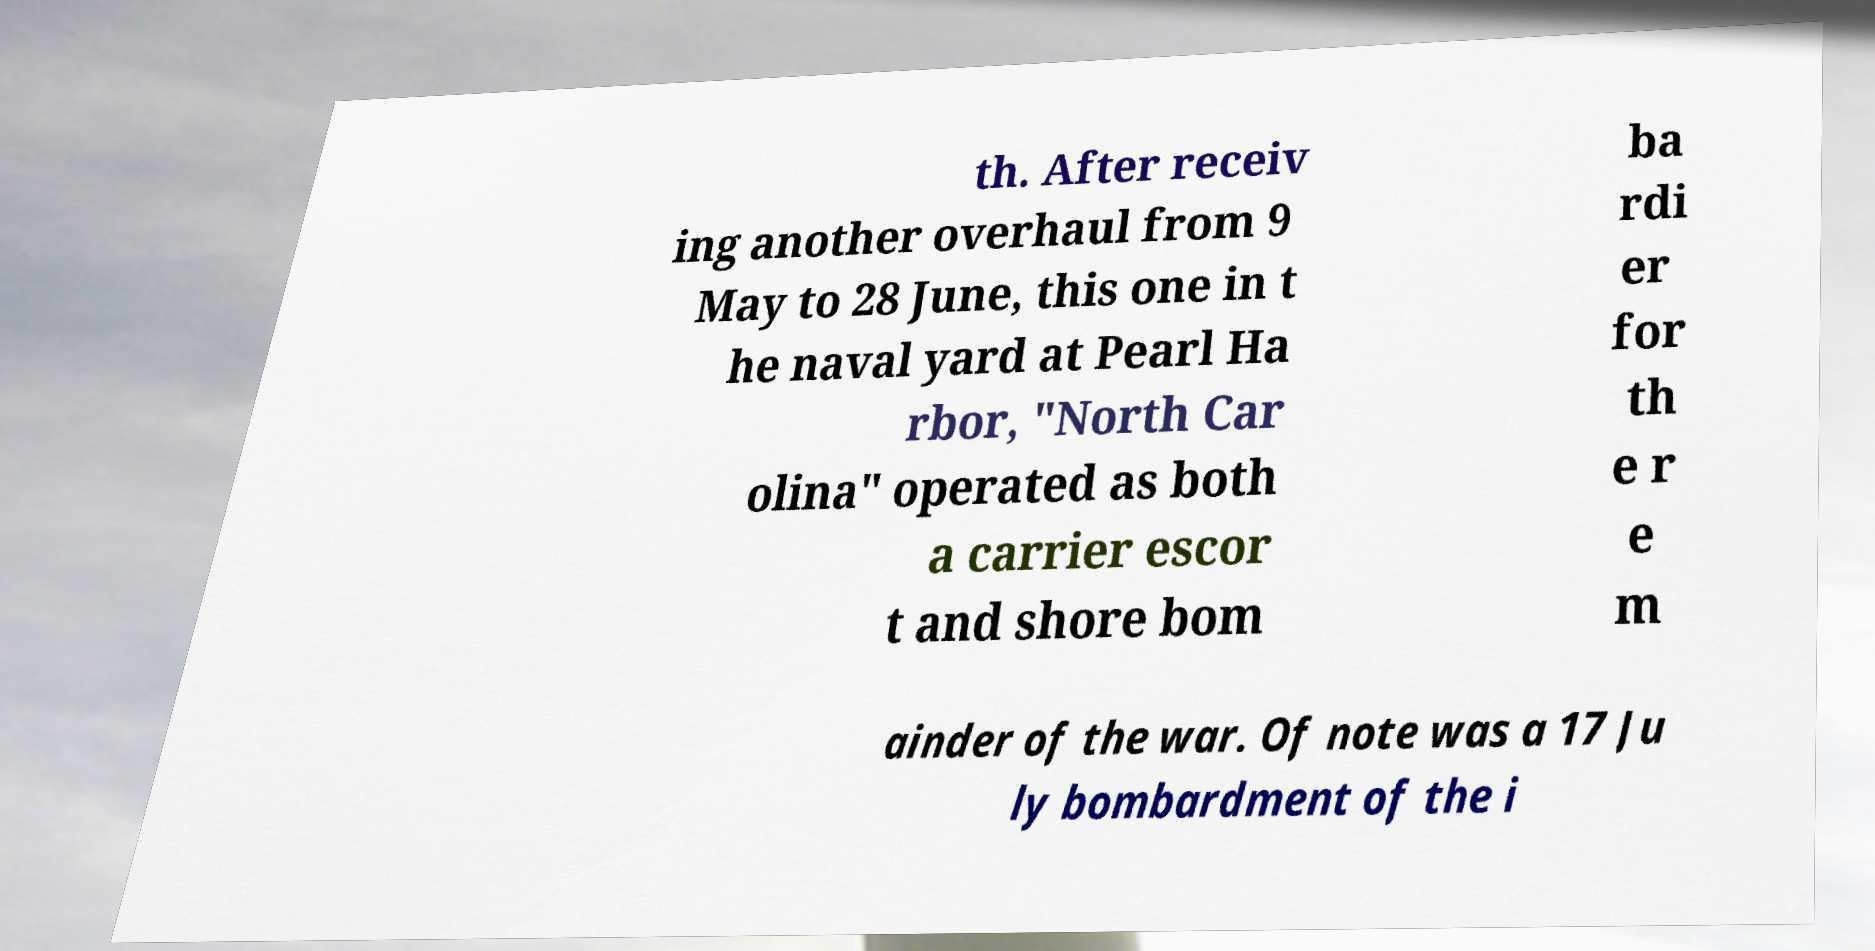Please read and relay the text visible in this image. What does it say? th. After receiv ing another overhaul from 9 May to 28 June, this one in t he naval yard at Pearl Ha rbor, "North Car olina" operated as both a carrier escor t and shore bom ba rdi er for th e r e m ainder of the war. Of note was a 17 Ju ly bombardment of the i 